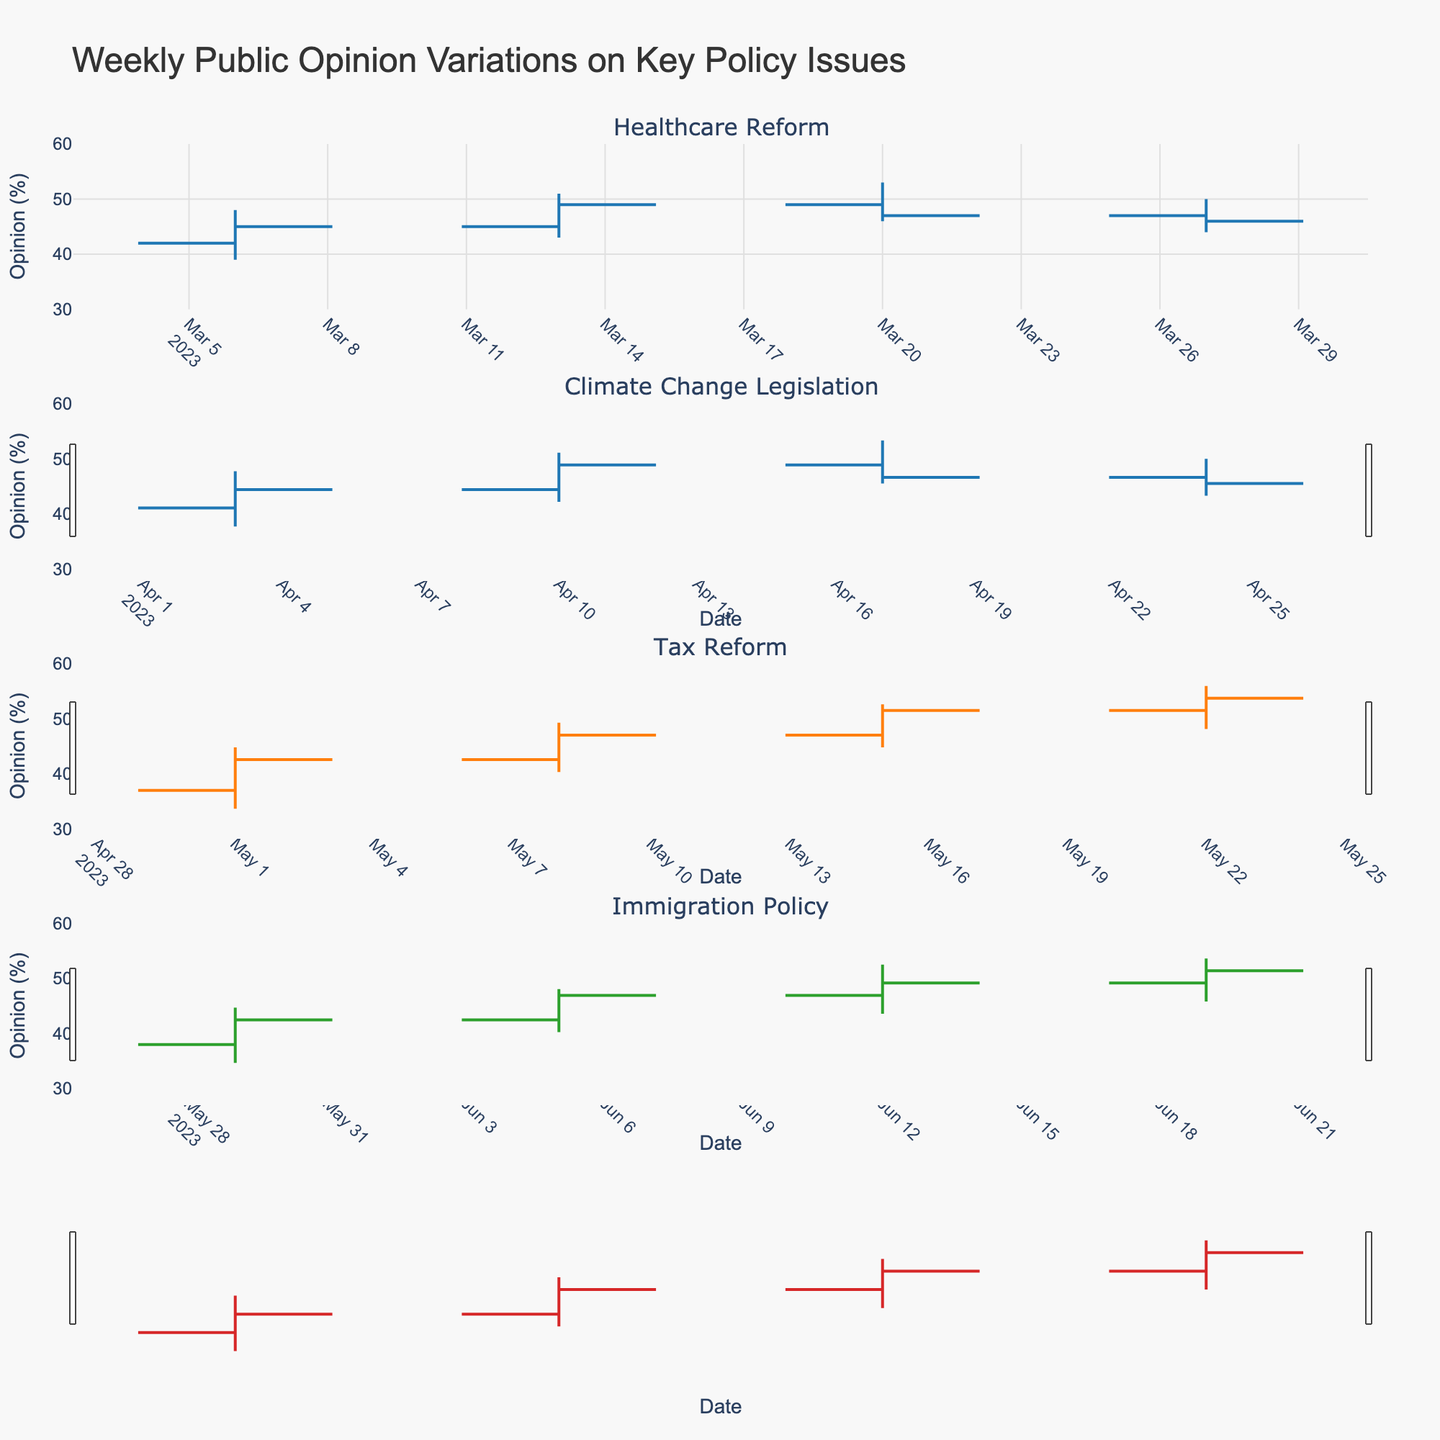What is the title of the figure? The figure's title is always placed at the top and is usually in larger, prominent font. In this case, it's "Weekly Public Opinion Variations on Key Policy Issues."
Answer: Weekly Public Opinion Variations on Key Policy Issues How many distinct issues are displayed in the figure? The issues are uniquely identified by the subplot titles. By reading each title, we see that there are four distinct issues: Healthcare Reform, Climate Change Legislation, Tax Reform, and Immigration Policy.
Answer: 4 On which date did the public opinion on Healthcare Reform reach its highest value, and what was that value? The highest value for Healthcare Reform is shown in the 'High' column for each date. By looking at the data, we see that the highest value is 53, which occurred on 2023-03-20.
Answer: 2023-03-20, 53 What was the average closing opinion value for Climate Change Legislation across the four dates? The closing values for Climate Change Legislation are 43, 47, 51, and 53. Adding them and then dividing by the number of data points (4) gives (43 + 47 + 51 + 53) / 4 = 194 / 4 = 48.5
Answer: 48.5 Which issue experienced the greatest single week increase in the closing value, and what was the increase? To find this, we subtract the closing value from one week from the closing value the previous week for each issue. For Healthcare Reform: (49-45), Climate Change Legislation: (47-43), Tax Reform: (48-44), Immigration Policy: (43-39). The greatest increase is 4 for Healthcare Reform.
Answer: Healthcare Reform, 4 Between 2023-04-03 and 2023-04-24, did the closing value of Climate Change Legislation consistently increase or decrease? Looking at the 'Close' values for Climate Change Legislation between these dates: (43, 47, 51, 53), it shows a consistent increase.
Answer: Increase For the issue of Tax Reform, what is the difference between the highest and lowest opening opinions? The highest and lowest opening opinions for Tax Reform are 50 and 40, respectively. Subtracting the lowest from the highest gives 50 - 40 = 10.
Answer: 10 Which date had the widest range for Immigration Policy, and what is the range? The range is calculated as the difference between the 'High' and 'Low' values. For Immigration Policy, check the data for each date: 2023-05-29 (42-33=9), 2023-06-05 (45-37=8), 2023-06-12 (48-40=8), and 2023-06-19 (51-43=8). The widest range is 9, occurring on 2023-05-29.
Answer: 2023-05-29, 9 